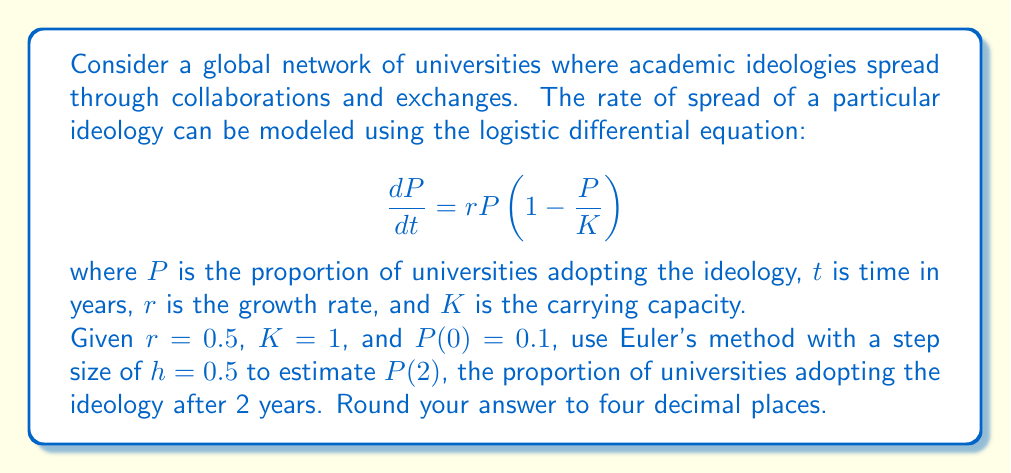Teach me how to tackle this problem. To solve this problem using Euler's method, we'll follow these steps:

1) Euler's method is given by the formula:
   $$P_{n+1} = P_n + h \cdot f(t_n, P_n)$$
   where $f(t, P) = rP(1-\frac{P}{K})$

2) We're given:
   $r = 0.5$, $K = 1$, $P(0) = 0.1$, $h = 0.5$

3) We need to iterate 4 times to reach $t = 2$ (since $2/0.5 = 4$):

   Step 1 ($t = 0$ to $t = 0.5$):
   $$f(0, 0.1) = 0.5 \cdot 0.1 \cdot (1 - 0.1/1) = 0.045$$
   $$P_1 = 0.1 + 0.5 \cdot 0.045 = 0.1225$$

   Step 2 ($t = 0.5$ to $t = 1$):
   $$f(0.5, 0.1225) = 0.5 \cdot 0.1225 \cdot (1 - 0.1225/1) \approx 0.0537$$
   $$P_2 = 0.1225 + 0.5 \cdot 0.0537 \approx 0.1494$$

   Step 3 ($t = 1$ to $t = 1.5$):
   $$f(1, 0.1494) = 0.5 \cdot 0.1494 \cdot (1 - 0.1494/1) \approx 0.0635$$
   $$P_3 = 0.1494 + 0.5 \cdot 0.0635 \approx 0.1812$$

   Step 4 ($t = 1.5$ to $t = 2$):
   $$f(1.5, 0.1812) = 0.5 \cdot 0.1812 \cdot (1 - 0.1812/1) \approx 0.0742$$
   $$P_4 = 0.1812 + 0.5 \cdot 0.0742 \approx 0.2183$$

4) Therefore, $P(2) \approx 0.2183$

5) Rounding to four decimal places: $P(2) \approx 0.2183$
Answer: 0.2183 